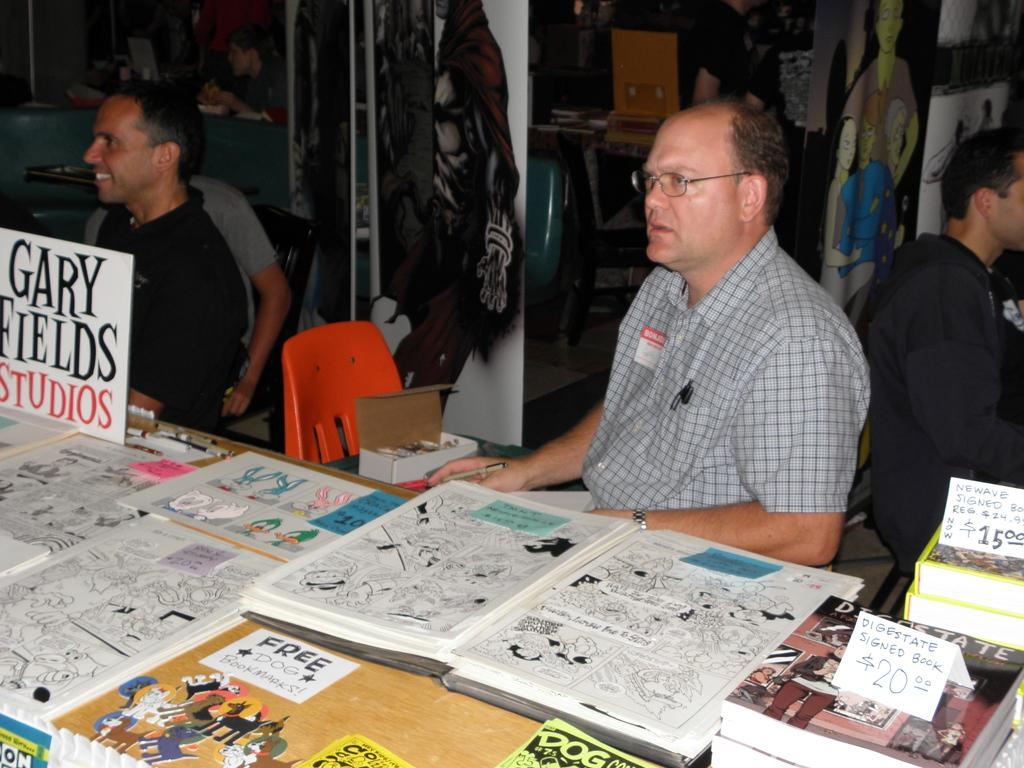<image>
Present a compact description of the photo's key features. A man sits near a sign that says Gary Fields Studios. 